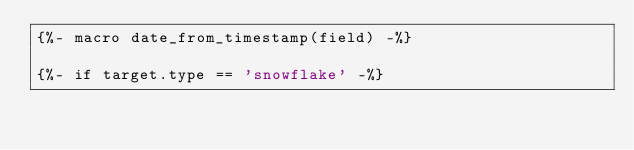Convert code to text. <code><loc_0><loc_0><loc_500><loc_500><_SQL_>{%- macro date_from_timestamp(field) -%}

{%- if target.type == 'snowflake' -%}</code> 